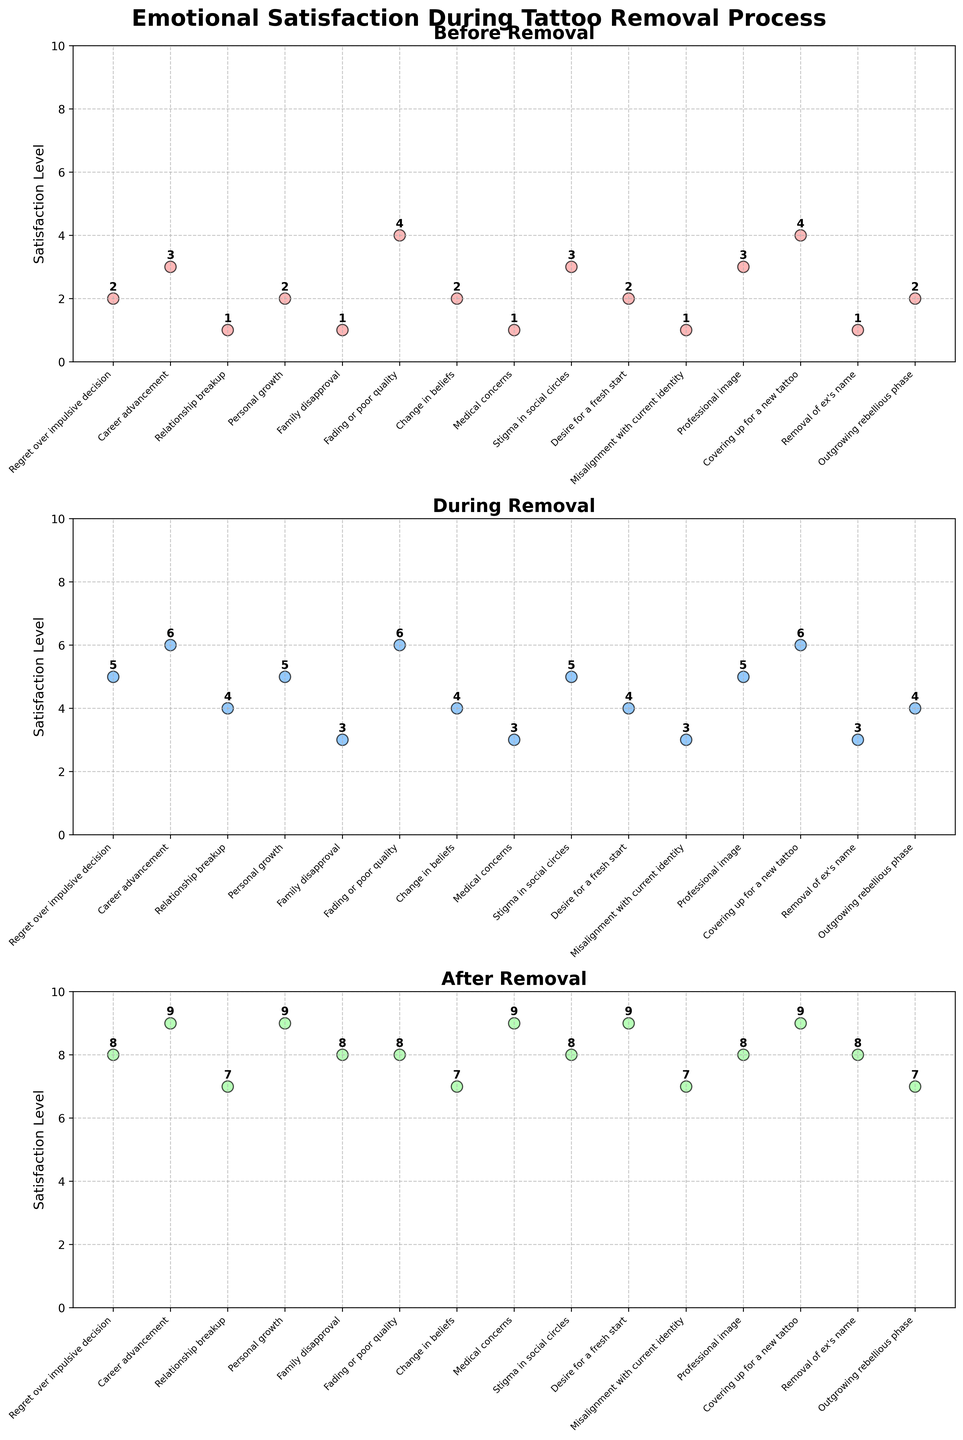what are the emotional satisfaction levels for "Career advancement" across all stages? Let's look at the scatter plot for all three stages. "During" has a level of 6, "Before" is at 3, and "After" at 9.
Answer: Levels are 3, 6, and 9 what is the average emotional satisfaction level during the tattoo removal process? To calculate this, sum all satisfaction levels during the tattoo removal and then divide by the number of data points: (5+6+4+5+3+6+4+3+5+4+3+5+6+3+4)/15 = 66/15 = 4.4
Answer: 4.4 which reason shows the greatest improvement in satisfaction from "Before" to "After"? We need to find the difference between "After" and "Before" for all reasons. "Desire for a fresh start" shows the greatest improvement: 9-2 = 7
Answer: Desire for a fresh start How does "Family disapproval" satisfaction level change through the stages? "Family disapproval" shows before: 1, during: 3, after: 8. So, changes are 1->3->8.
Answer: Changes from 1 to 3 to 8 Which stage generally shows the highest emotional satisfaction levels? "After" shows the highest levels as more data points are at 7-9 range compared to the other stages.
Answer: After For "Medical concerns", what is the combined satisfaction level for all stages? Sum the levels before, during, and after for "Medical concerns": 1 + 3 + 9 = 13
Answer: 13 Are there any reasons where the emotional satisfaction levels are equal between "Before" and "After"? We compare the levels of each reason. None show equal satisfaction levels between "Before" and "After".
Answer: None What is the median satisfaction level "After" the tattoo removal process? Sorted satisfaction levels "After" are: 7,7,7,7,8,8,8,8,8,8,9,9,9,9,9, median = (8+8)/2 = 8
Answer: 8 